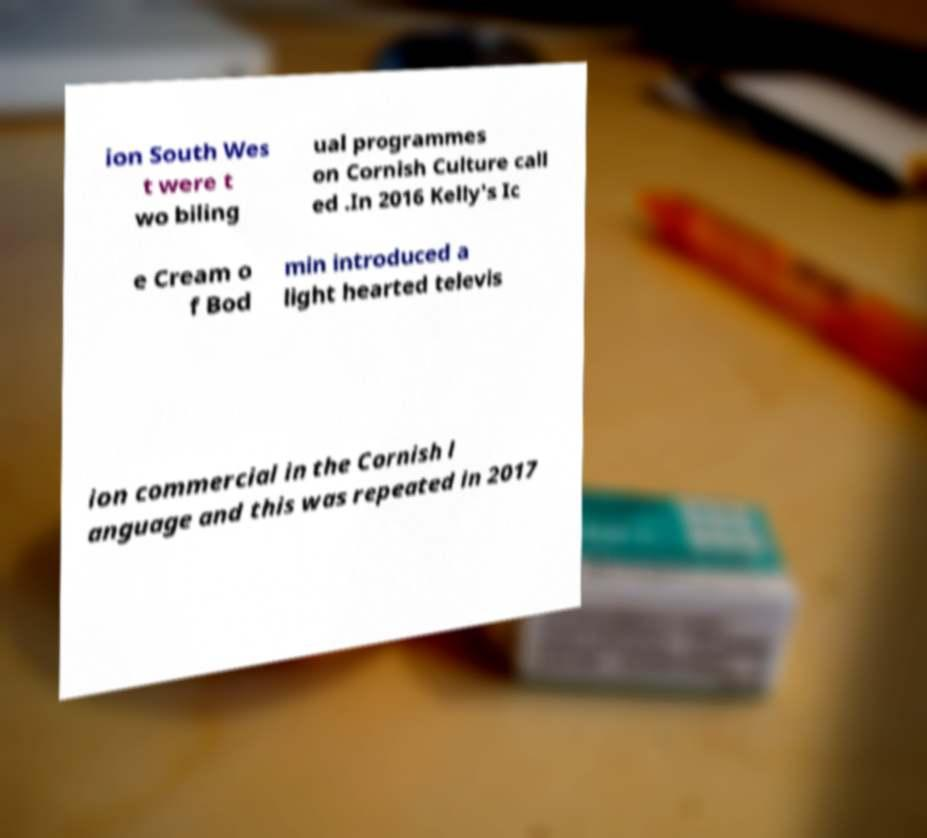Can you accurately transcribe the text from the provided image for me? ion South Wes t were t wo biling ual programmes on Cornish Culture call ed .In 2016 Kelly's Ic e Cream o f Bod min introduced a light hearted televis ion commercial in the Cornish l anguage and this was repeated in 2017 